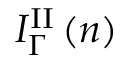Convert formula to latex. <formula><loc_0><loc_0><loc_500><loc_500>I _ { \Gamma } ^ { I I } \left ( n \right )</formula> 